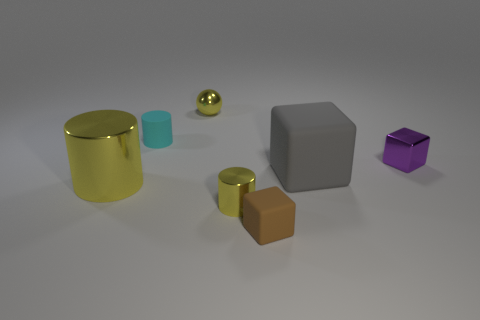Subtract 1 cylinders. How many cylinders are left? 2 Subtract all yellow balls. How many yellow cylinders are left? 2 Subtract all matte blocks. How many blocks are left? 1 Add 3 large green rubber spheres. How many objects exist? 10 Subtract all spheres. How many objects are left? 6 Add 1 yellow shiny cylinders. How many yellow shiny cylinders exist? 3 Subtract 0 green blocks. How many objects are left? 7 Subtract all small purple shiny blocks. Subtract all cyan cylinders. How many objects are left? 5 Add 6 small yellow things. How many small yellow things are left? 8 